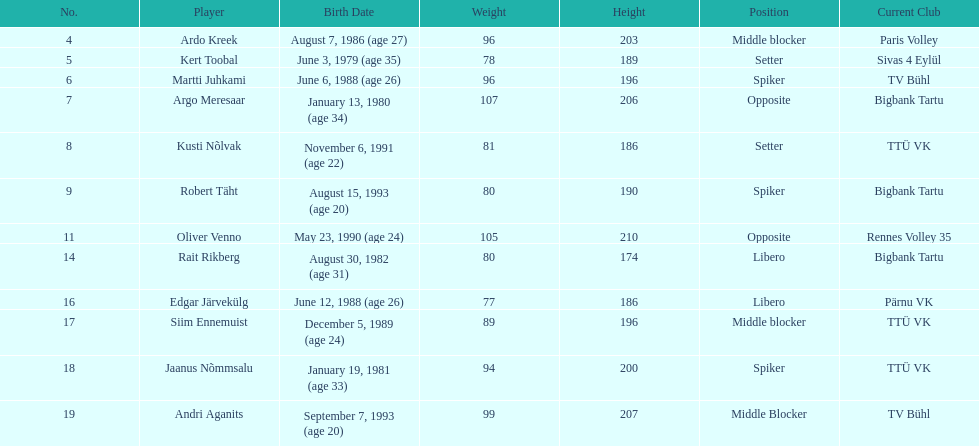In estonia's men's national volleyball team, how many players were born in 1988? 2. 